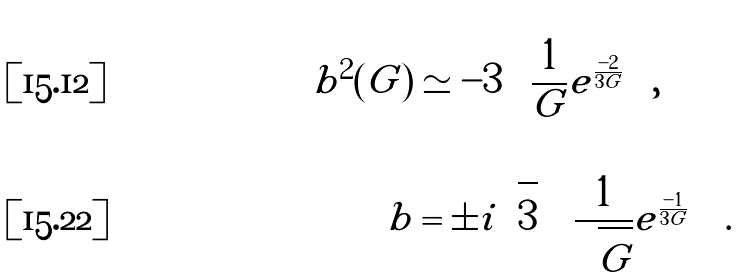<formula> <loc_0><loc_0><loc_500><loc_500>b ^ { 2 } ( G ) & \simeq - 3 \left ( \frac { 1 } { G } e ^ { \frac { - 2 } { 3 G } } \right ) , \\ b & = \pm i \sqrt { 3 } \left ( \frac { 1 } { \sqrt { G } } e ^ { \frac { - 1 } { 3 G } } \right ) .</formula> 